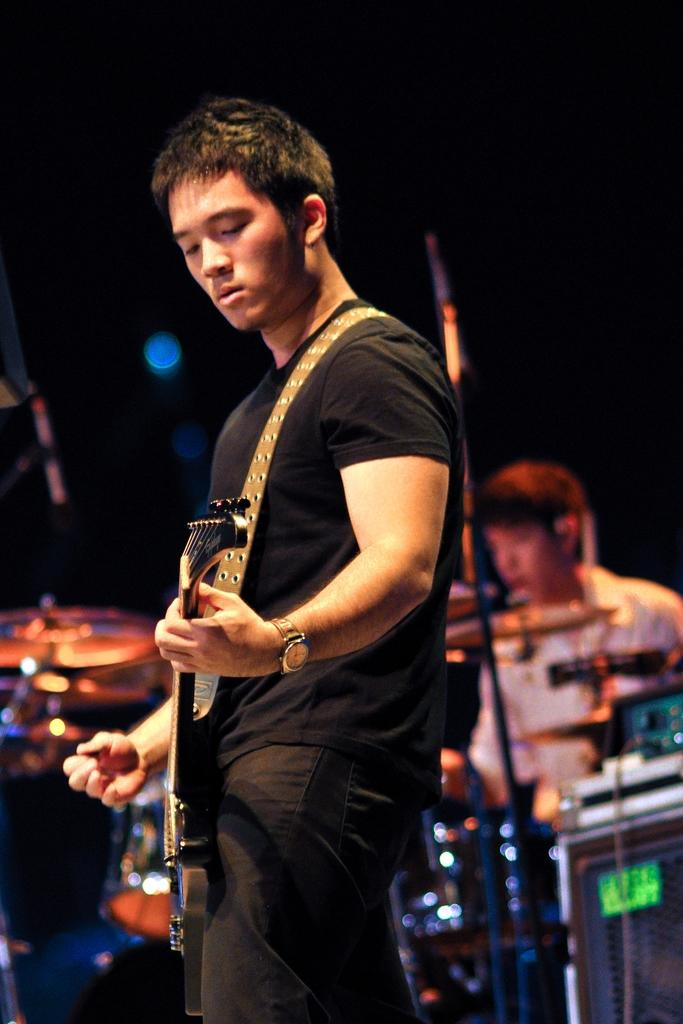How many people are in the image? There are two persons in the image. What is one person doing in the image? One person is holding a guitar and playing it. What is the other person doing in the image? The other person is sitting and playing drums. What type of receipt can be seen in the image? There is no receipt present in the image. Is the scene taking place during winter, as indicated by the presence of snow or winter clothing? The image does not provide any information about the season or weather, so it cannot be determined if it is winter. 